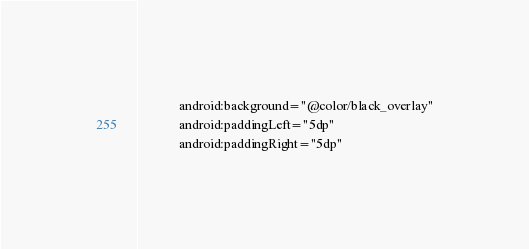<code> <loc_0><loc_0><loc_500><loc_500><_XML_>            android:background="@color/black_overlay"
            android:paddingLeft="5dp"
            android:paddingRight="5dp"</code> 